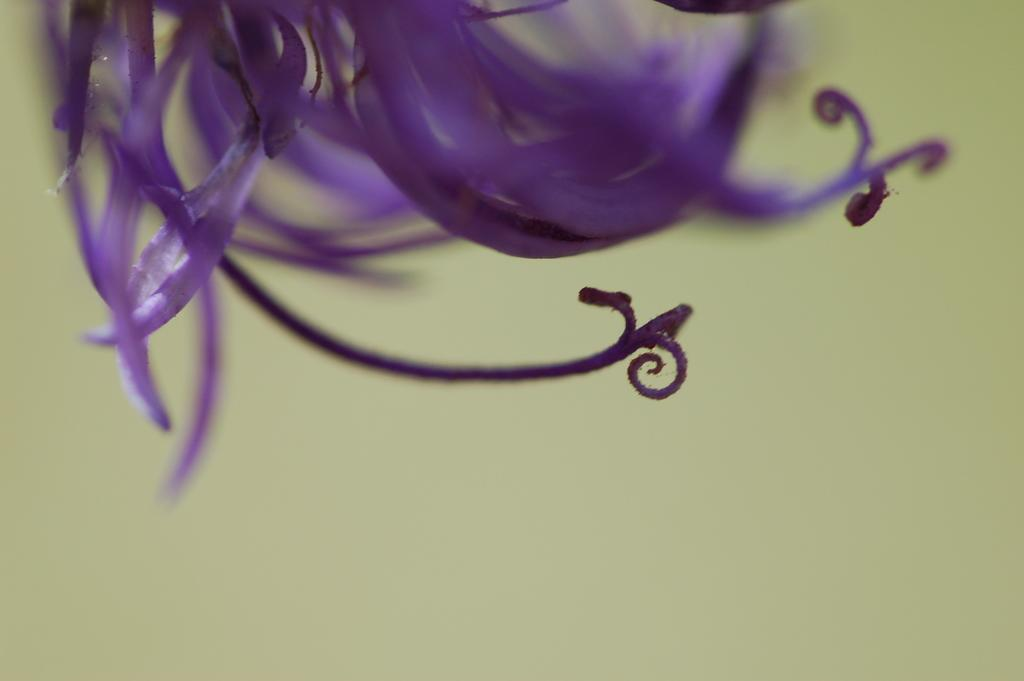What type of image is shown? The image is a zoom-in picture. What can be seen in the zoom-in picture? There is a purple color flower in the image. What type of fear does the flower have in the image? The flower does not have any fear in the image, as it is an inanimate object. What type of hook is attached to the flower in the image? There is no hook attached to the flower in the image. 